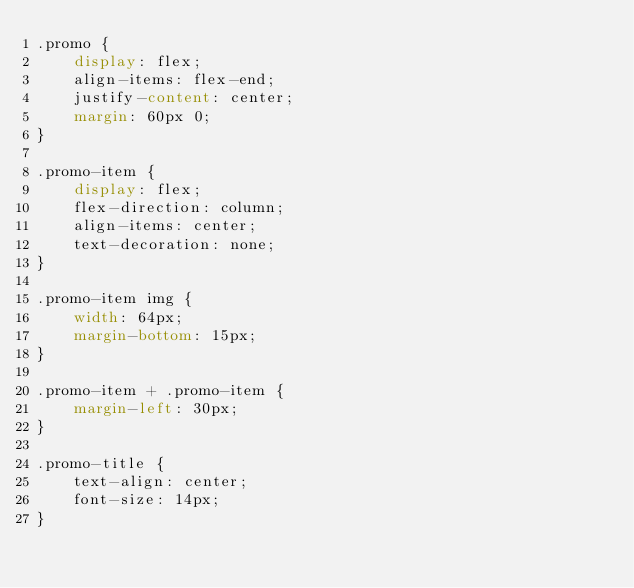Convert code to text. <code><loc_0><loc_0><loc_500><loc_500><_CSS_>.promo {
    display: flex;
    align-items: flex-end;
    justify-content: center;
    margin: 60px 0;
}

.promo-item {
    display: flex;
    flex-direction: column;
    align-items: center;
    text-decoration: none;
}

.promo-item img {
    width: 64px;
    margin-bottom: 15px;
}

.promo-item + .promo-item {
    margin-left: 30px;
}

.promo-title {
    text-align: center;
    font-size: 14px;
}
</code> 